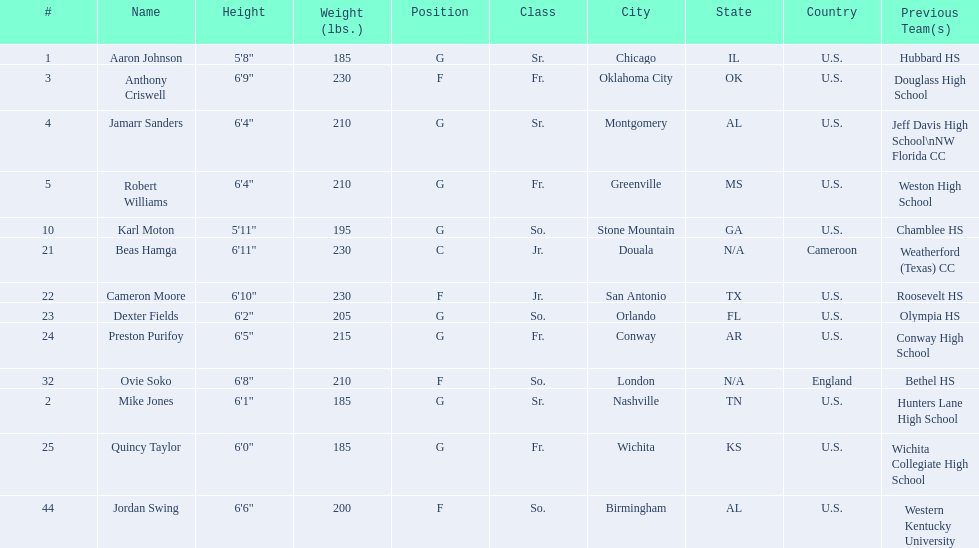How many total forwards are on the team? 4. 